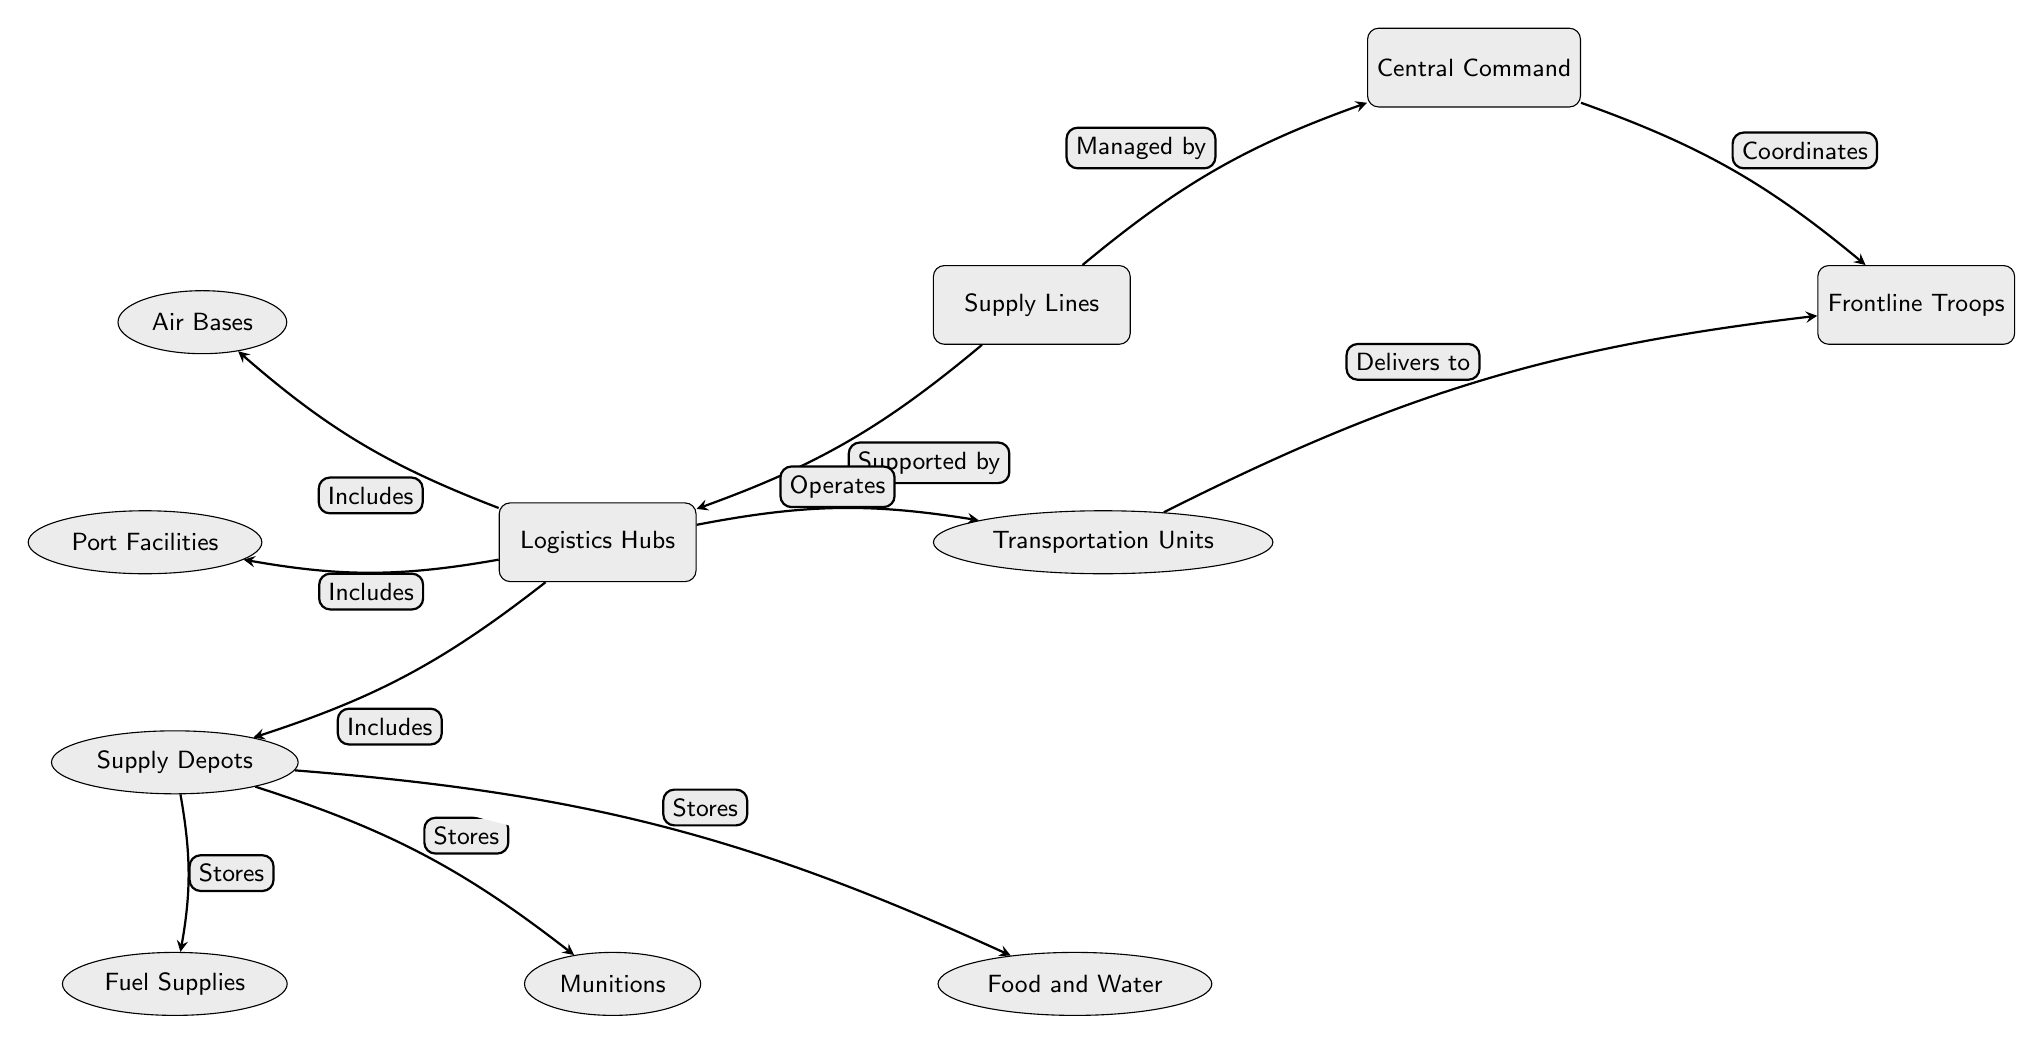What is the main focus of the diagram? The main focus of the diagram is the relationships and components of supply lines during Operation Desert Storm, illustrated through nodes such as Central Command, Logistics Hubs, and Frontline Troops.
Answer: Supply Lines How many types of logistics hubs are described in the diagram? The diagram outlines four types of logistics hubs: Air Bases, Port Facilities, Supply Depots, and Transportation Units. Counting these sub-nodes gives the answer.
Answer: Four Which node coordinates with the frontline troops? The Central Command node has a directed edge that explicitly indicates it coordinates with the Frontline Troops, showing the flow of decision-making.
Answer: Central Command What does the supply depots node store? The Supply Depots node stores three types of supplies: Fuel Supplies, Munitions, and Food and Water, as indicated by the arrows leading from Depots to each.
Answer: Fuel Supplies, Munitions, Food and Water What role do transportation units play in the diagram? The Transportation Units operate under Logistics Hubs and have a directed edge that shows they deliver supplies to the Frontline Troops, clarifying their function.
Answer: Delivers to Troops Which two main nodes are supported by logistics? The Supply Lines node is supported by Logistics Hubs and also managed by Central Command, illustrating the collaborative structure of military logistics.
Answer: Central Command, Logistics Hubs What are the edges indicating between the supply depots and the supplies? The edges show that Supply Depots stores Fuel Supplies, Munitions, and Food and Water, making it clear that it is a storage hub for these critical supplies.
Answer: Stores How does the Central Command interact with the supply lines? Central Command is indicated to manage the supply lines, establishing a direct connection in the flow of the diagram that shows its oversight role.
Answer: Managed by What is the relationship between logistics hubs and transportation units? The diagram illustrates a direct connection where logistics hubs operate transportation units, indicating their reliance on logistics for movement and support.
Answer: Operates 